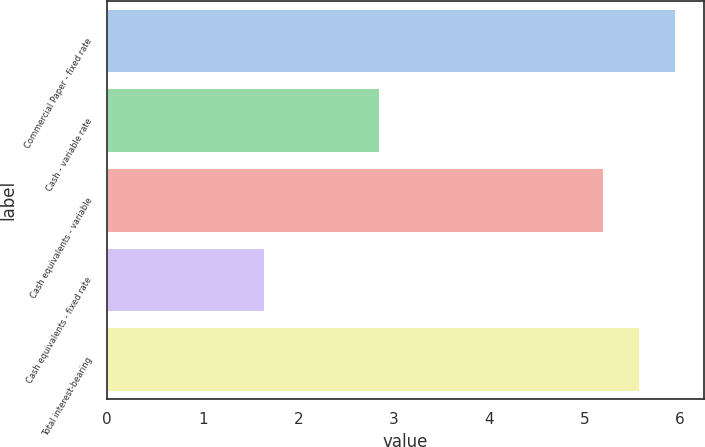Convert chart. <chart><loc_0><loc_0><loc_500><loc_500><bar_chart><fcel>Commercial Paper - fixed rate<fcel>Cash - variable rate<fcel>Cash equivalents - variable<fcel>Cash equivalents - fixed rate<fcel>Total interest-bearing<nl><fcel>5.95<fcel>2.85<fcel>5.19<fcel>1.64<fcel>5.57<nl></chart> 